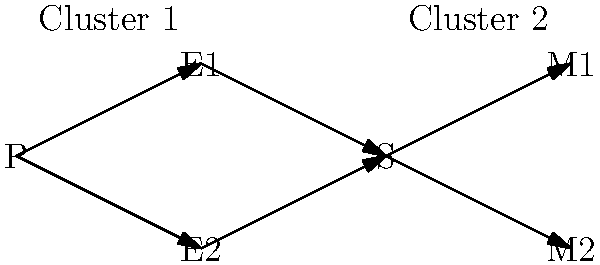Given the graph representing communication patterns in your racing team, where P is the pit crew, E1 and E2 are engineers, S is you (the driver), and M1 and M2 are mechanics, which clustering technique would be most appropriate to identify the two main communication groups, and what insight can be gained from this analysis? To answer this question, let's follow these steps:

1. Analyze the graph structure:
   - The graph shows two distinct groups of nodes.
   - Group 1: P (pit crew), E1, E2 (engineers), and S (driver)
   - Group 2: S (driver), M1, and M2 (mechanics)

2. Identify the clustering technique:
   - The most appropriate technique for this scenario is community detection.
   - Specifically, the Girvan-Newman algorithm would work well here.

3. Apply the Girvan-Newman algorithm:
   - This algorithm identifies edges with high betweenness centrality.
   - In this graph, the edge between S and the rest of the nodes has the highest betweenness.
   - Removing this edge would reveal the two clusters.

4. Interpret the results:
   - Cluster 1 represents pre-race planning and strategy.
   - Cluster 2 represents in-race mechanical support.

5. Gain insights:
   - The driver (S) acts as a bridge between the two clusters.
   - This indicates that the driver plays a crucial role in information flow.
   - It suggests that improving the driver's communication skills could enhance overall team performance.

6. Potential improvements:
   - Introduce direct communication channels between engineers and mechanics.
   - This could lead to faster problem-solving during races.

By using graph clustering techniques, we can identify communication bottlenecks and optimize information flow within the racing team, ultimately improving race performance.
Answer: Girvan-Newman algorithm; driver is key communication link between strategy and mechanical clusters. 